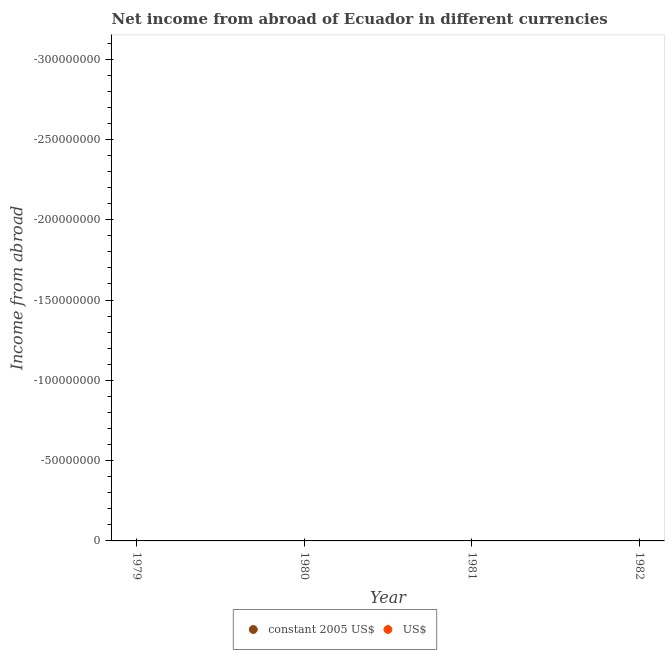Is the number of dotlines equal to the number of legend labels?
Your answer should be very brief. No. Across all years, what is the minimum income from abroad in us$?
Provide a short and direct response. 0. What is the average income from abroad in us$ per year?
Offer a very short reply. 0. Is the income from abroad in constant 2005 us$ strictly greater than the income from abroad in us$ over the years?
Your answer should be very brief. Yes. Are the values on the major ticks of Y-axis written in scientific E-notation?
Ensure brevity in your answer.  No. Does the graph contain any zero values?
Ensure brevity in your answer.  Yes. Does the graph contain grids?
Your answer should be very brief. No. Where does the legend appear in the graph?
Offer a terse response. Bottom center. What is the title of the graph?
Offer a very short reply. Net income from abroad of Ecuador in different currencies. What is the label or title of the X-axis?
Offer a terse response. Year. What is the label or title of the Y-axis?
Keep it short and to the point. Income from abroad. What is the Income from abroad of US$ in 1979?
Provide a short and direct response. 0. What is the Income from abroad of constant 2005 US$ in 1980?
Keep it short and to the point. 0. What is the Income from abroad in US$ in 1980?
Provide a short and direct response. 0. What is the Income from abroad of constant 2005 US$ in 1982?
Keep it short and to the point. 0. What is the Income from abroad of US$ in 1982?
Ensure brevity in your answer.  0. What is the total Income from abroad in US$ in the graph?
Offer a terse response. 0. What is the average Income from abroad of constant 2005 US$ per year?
Give a very brief answer. 0. 